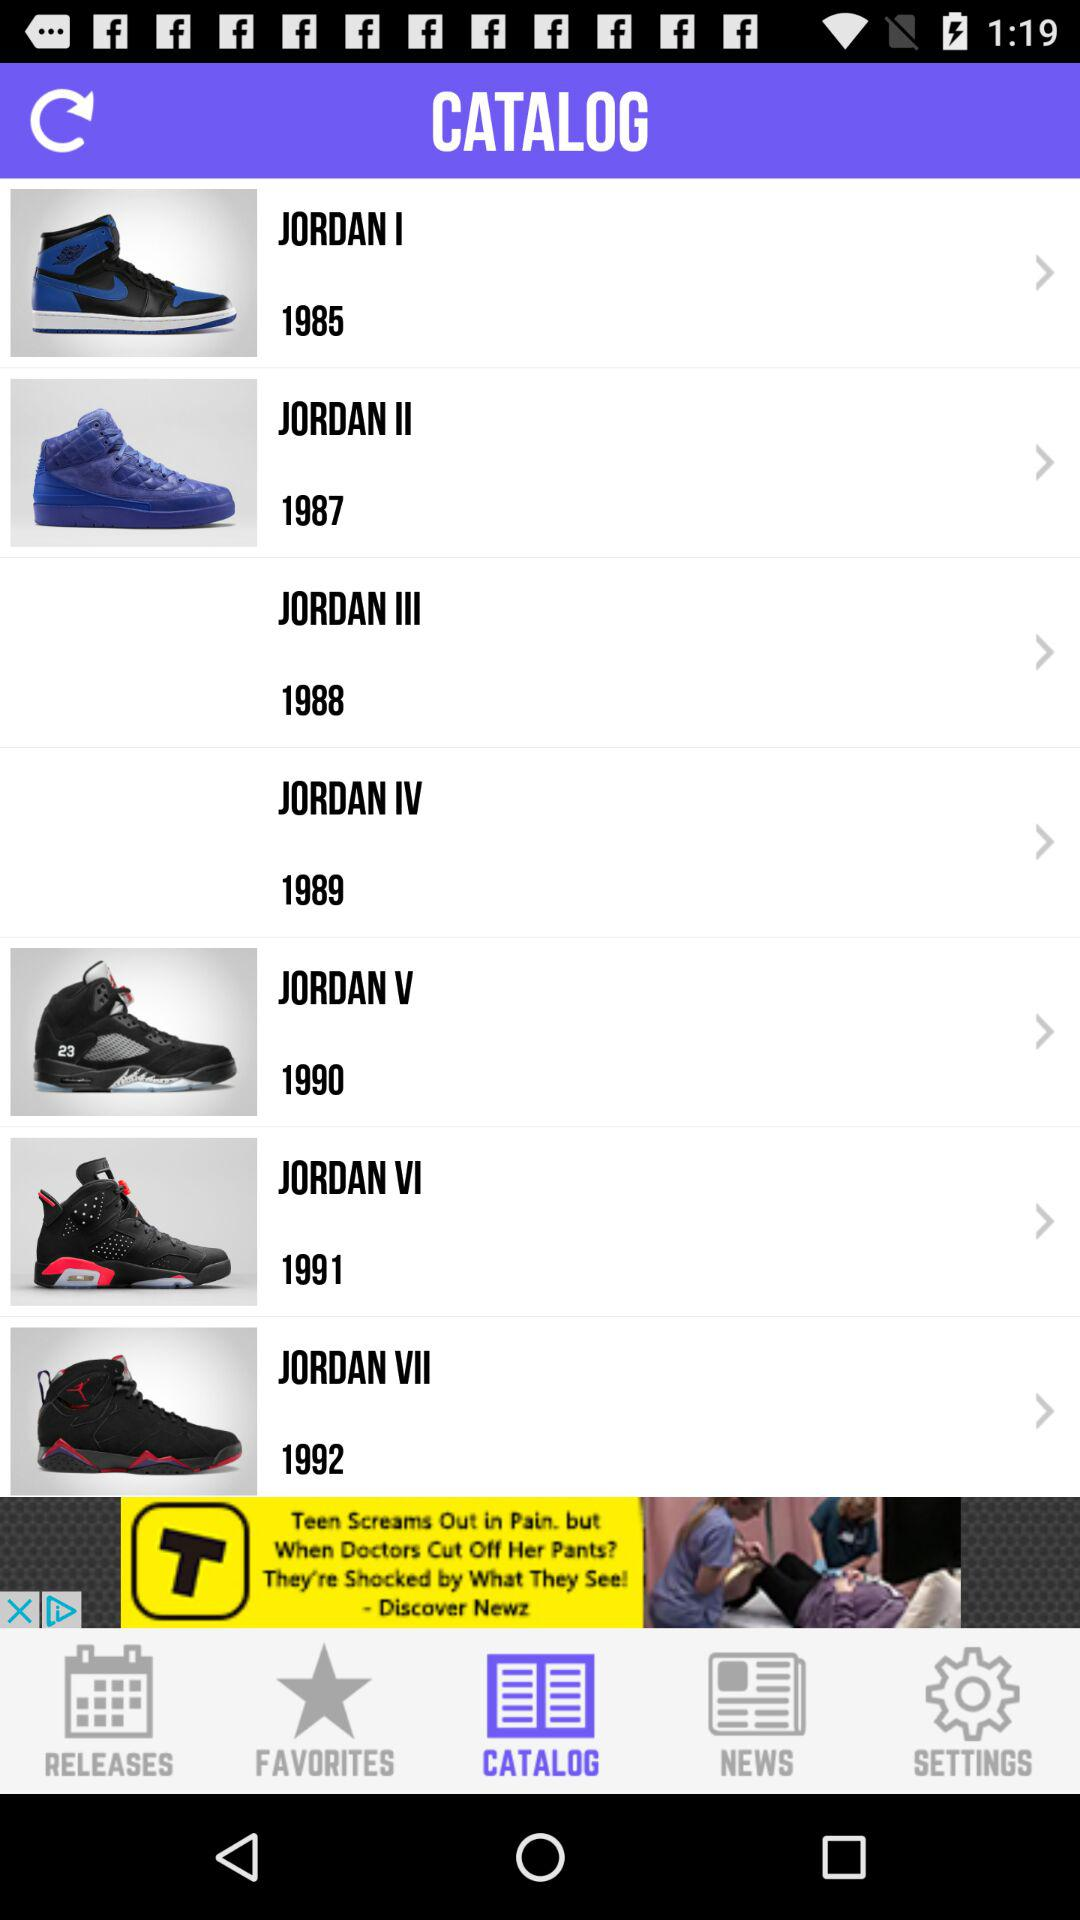How many shoes are in the catalog?
Answer the question using a single word or phrase. 7 